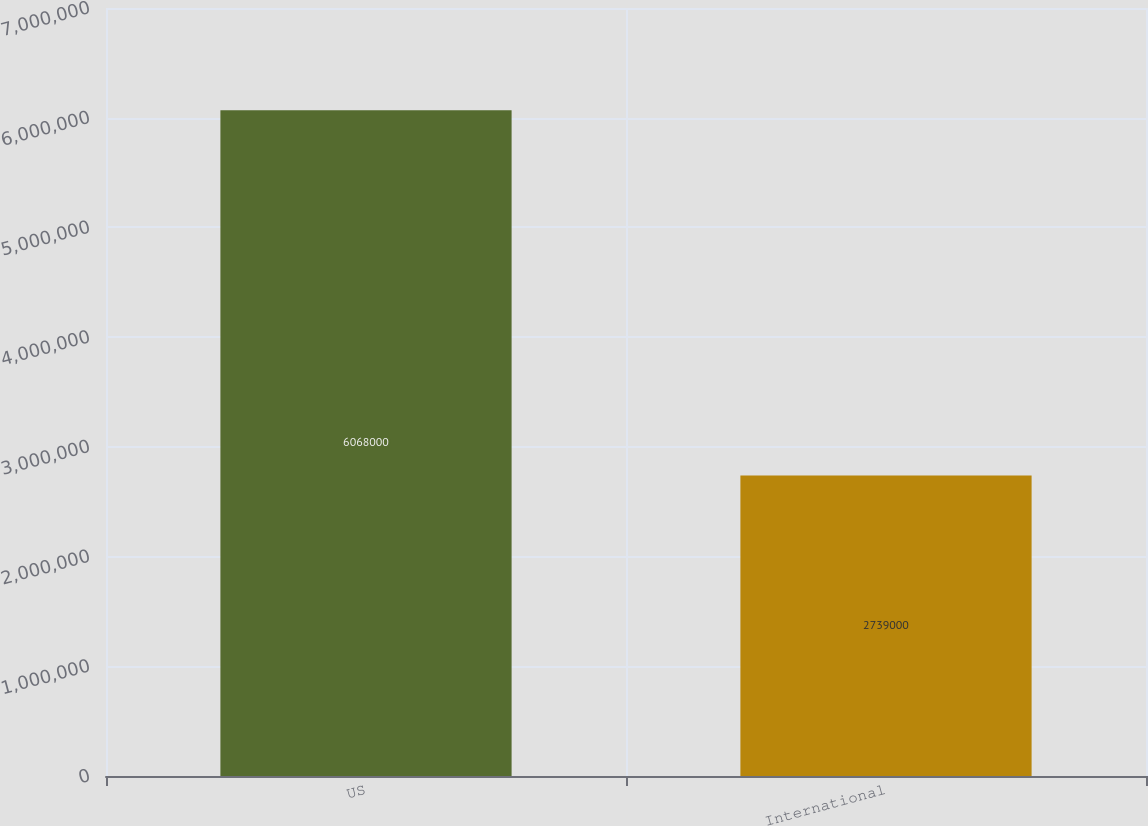Convert chart to OTSL. <chart><loc_0><loc_0><loc_500><loc_500><bar_chart><fcel>US<fcel>International<nl><fcel>6.068e+06<fcel>2.739e+06<nl></chart> 